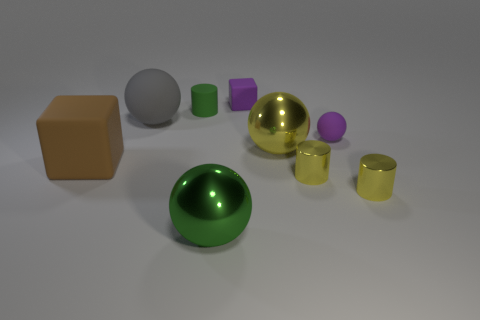Add 1 tiny red things. How many objects exist? 10 Subtract all cylinders. How many objects are left? 6 Subtract 0 cyan spheres. How many objects are left? 9 Subtract all green rubber things. Subtract all large green metal spheres. How many objects are left? 7 Add 4 tiny cubes. How many tiny cubes are left? 5 Add 6 matte cubes. How many matte cubes exist? 8 